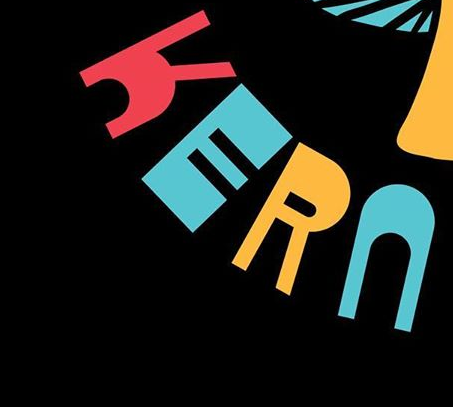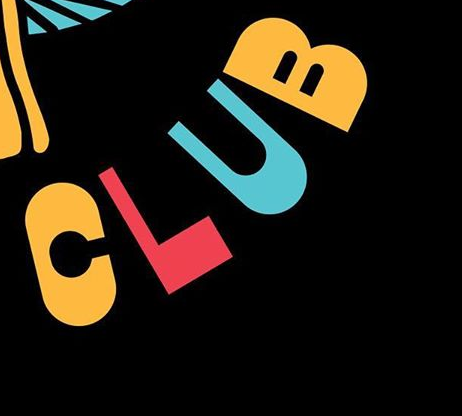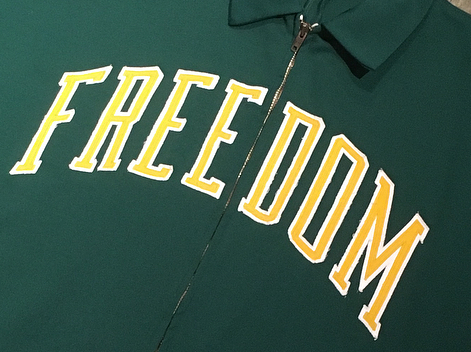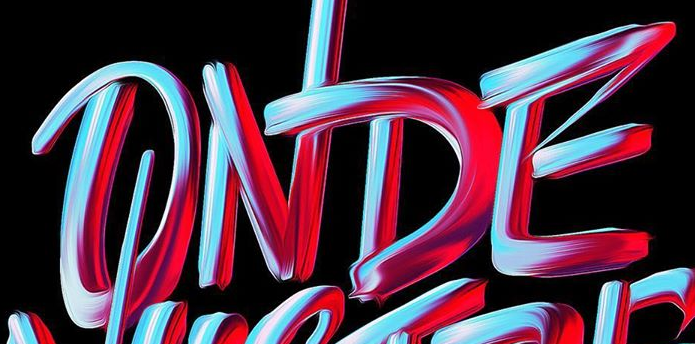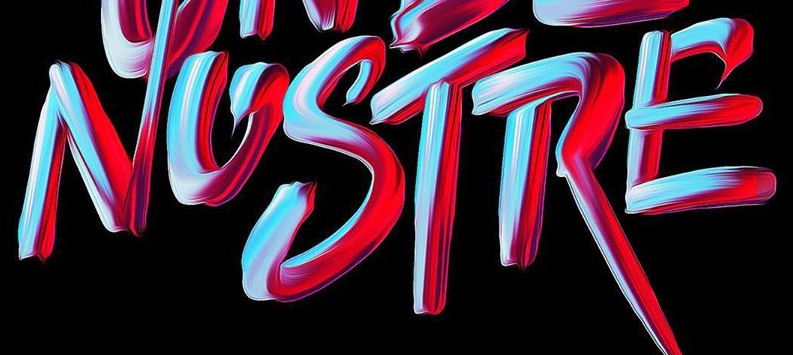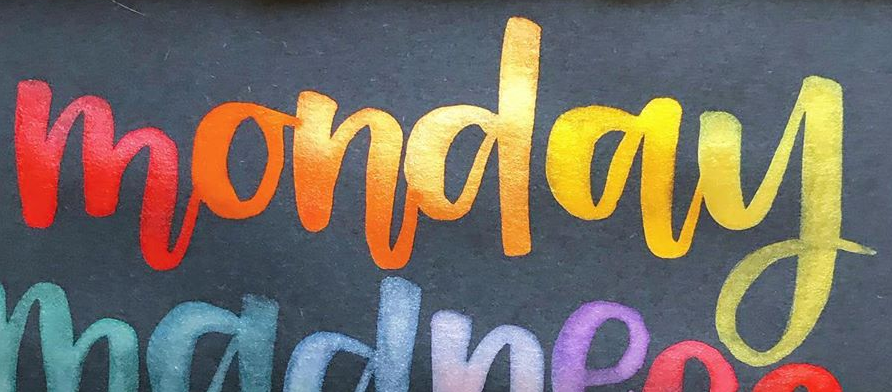What text is displayed in these images sequentially, separated by a semicolon? KERN; CLUB; FREEDOM; ONDE; NOSTRE; monday 